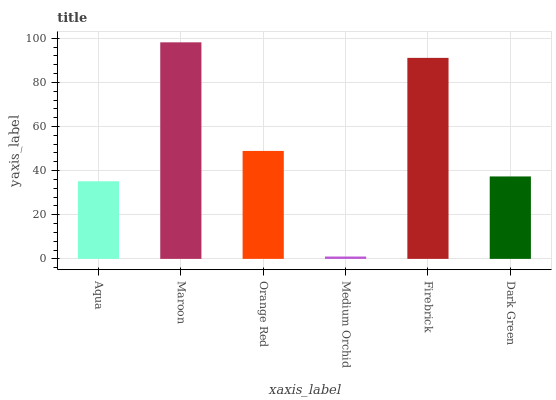Is Orange Red the minimum?
Answer yes or no. No. Is Orange Red the maximum?
Answer yes or no. No. Is Maroon greater than Orange Red?
Answer yes or no. Yes. Is Orange Red less than Maroon?
Answer yes or no. Yes. Is Orange Red greater than Maroon?
Answer yes or no. No. Is Maroon less than Orange Red?
Answer yes or no. No. Is Orange Red the high median?
Answer yes or no. Yes. Is Dark Green the low median?
Answer yes or no. Yes. Is Maroon the high median?
Answer yes or no. No. Is Maroon the low median?
Answer yes or no. No. 